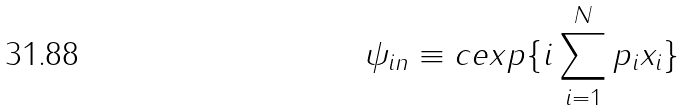Convert formula to latex. <formula><loc_0><loc_0><loc_500><loc_500>\psi _ { i n } \equiv c e x p \{ i \sum _ { i = 1 } ^ { N } p _ { i } x _ { i } \}</formula> 